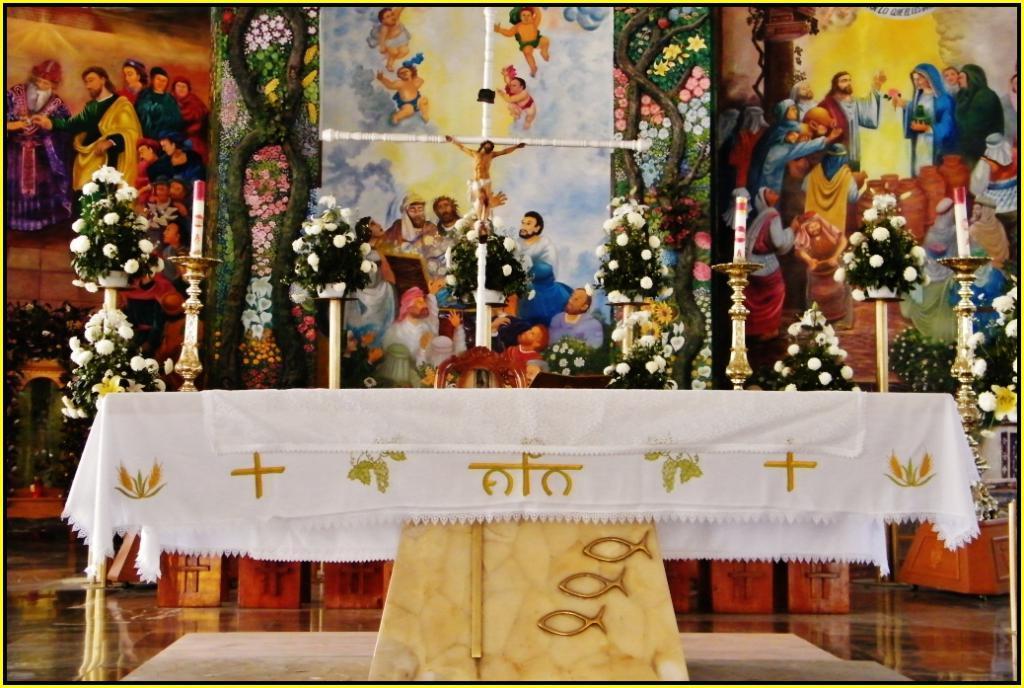Can you describe this image briefly? In this image I can see few paintings and flower bouquets. There are few objects on the table. I can see a white cloth on the table. There are few paintings on the cloth. At the bottom I can see some carvings on the wooden object. 